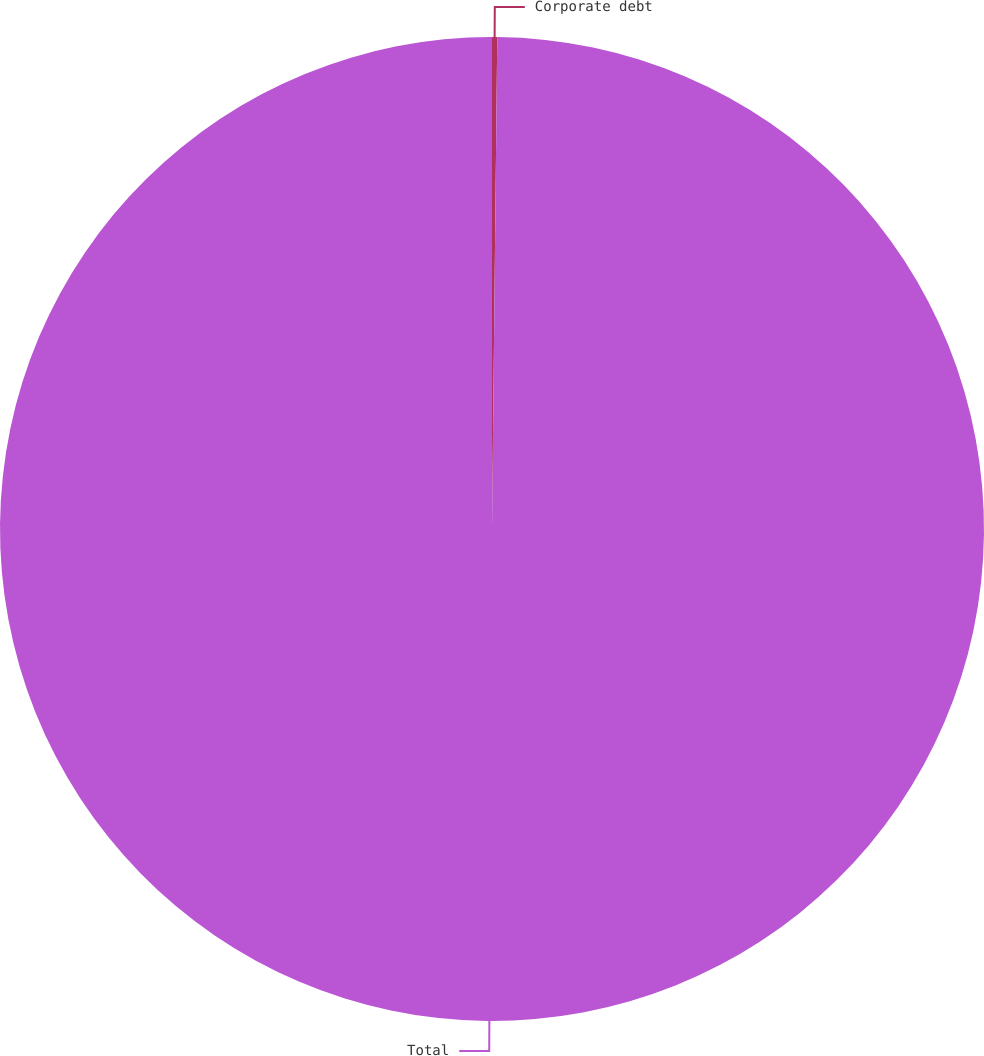<chart> <loc_0><loc_0><loc_500><loc_500><pie_chart><fcel>Corporate debt<fcel>Total<nl><fcel>0.17%<fcel>99.83%<nl></chart> 